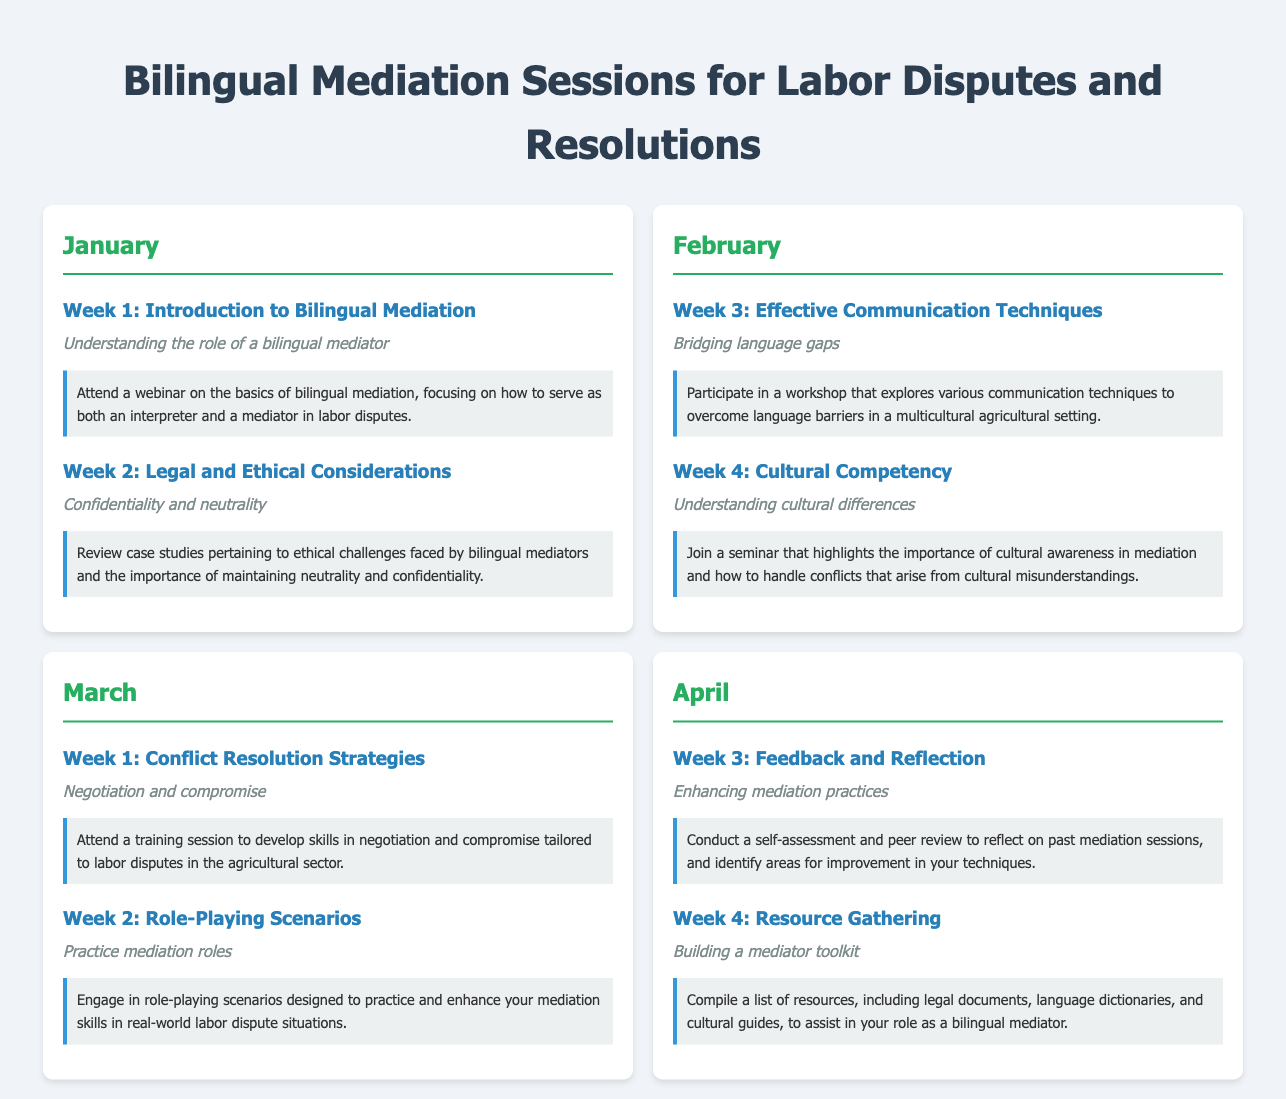what is the title of the document? The title is prominently displayed at the top of the document.
Answer: Bilingual Mediation Sessions for Labor Disputes and Resolutions how many weeks are covered in January? Each month has two weeks outlined; this is true for January as well.
Answer: 2 what is the focus of Week 1 in January? The focus is detailed in the heading of Week 1, specifying the topic being addressed.
Answer: Introduction to Bilingual Mediation which month features a seminar on cultural competency? The month is indicated as the one where that seminar takes place.
Answer: February what is the subtopic of Week 4 in April? The subtopic is mentioned under Week 4, providing insight into the session's content.
Answer: Building a mediator toolkit which week contains a workshop for communication techniques? The week number is given, referring to the specific topic outlined.
Answer: Week 3 how is the self-assessment conducted in April characterized? The description reveals the purpose of the self-assessment in that week.
Answer: Feedback and Reflection 